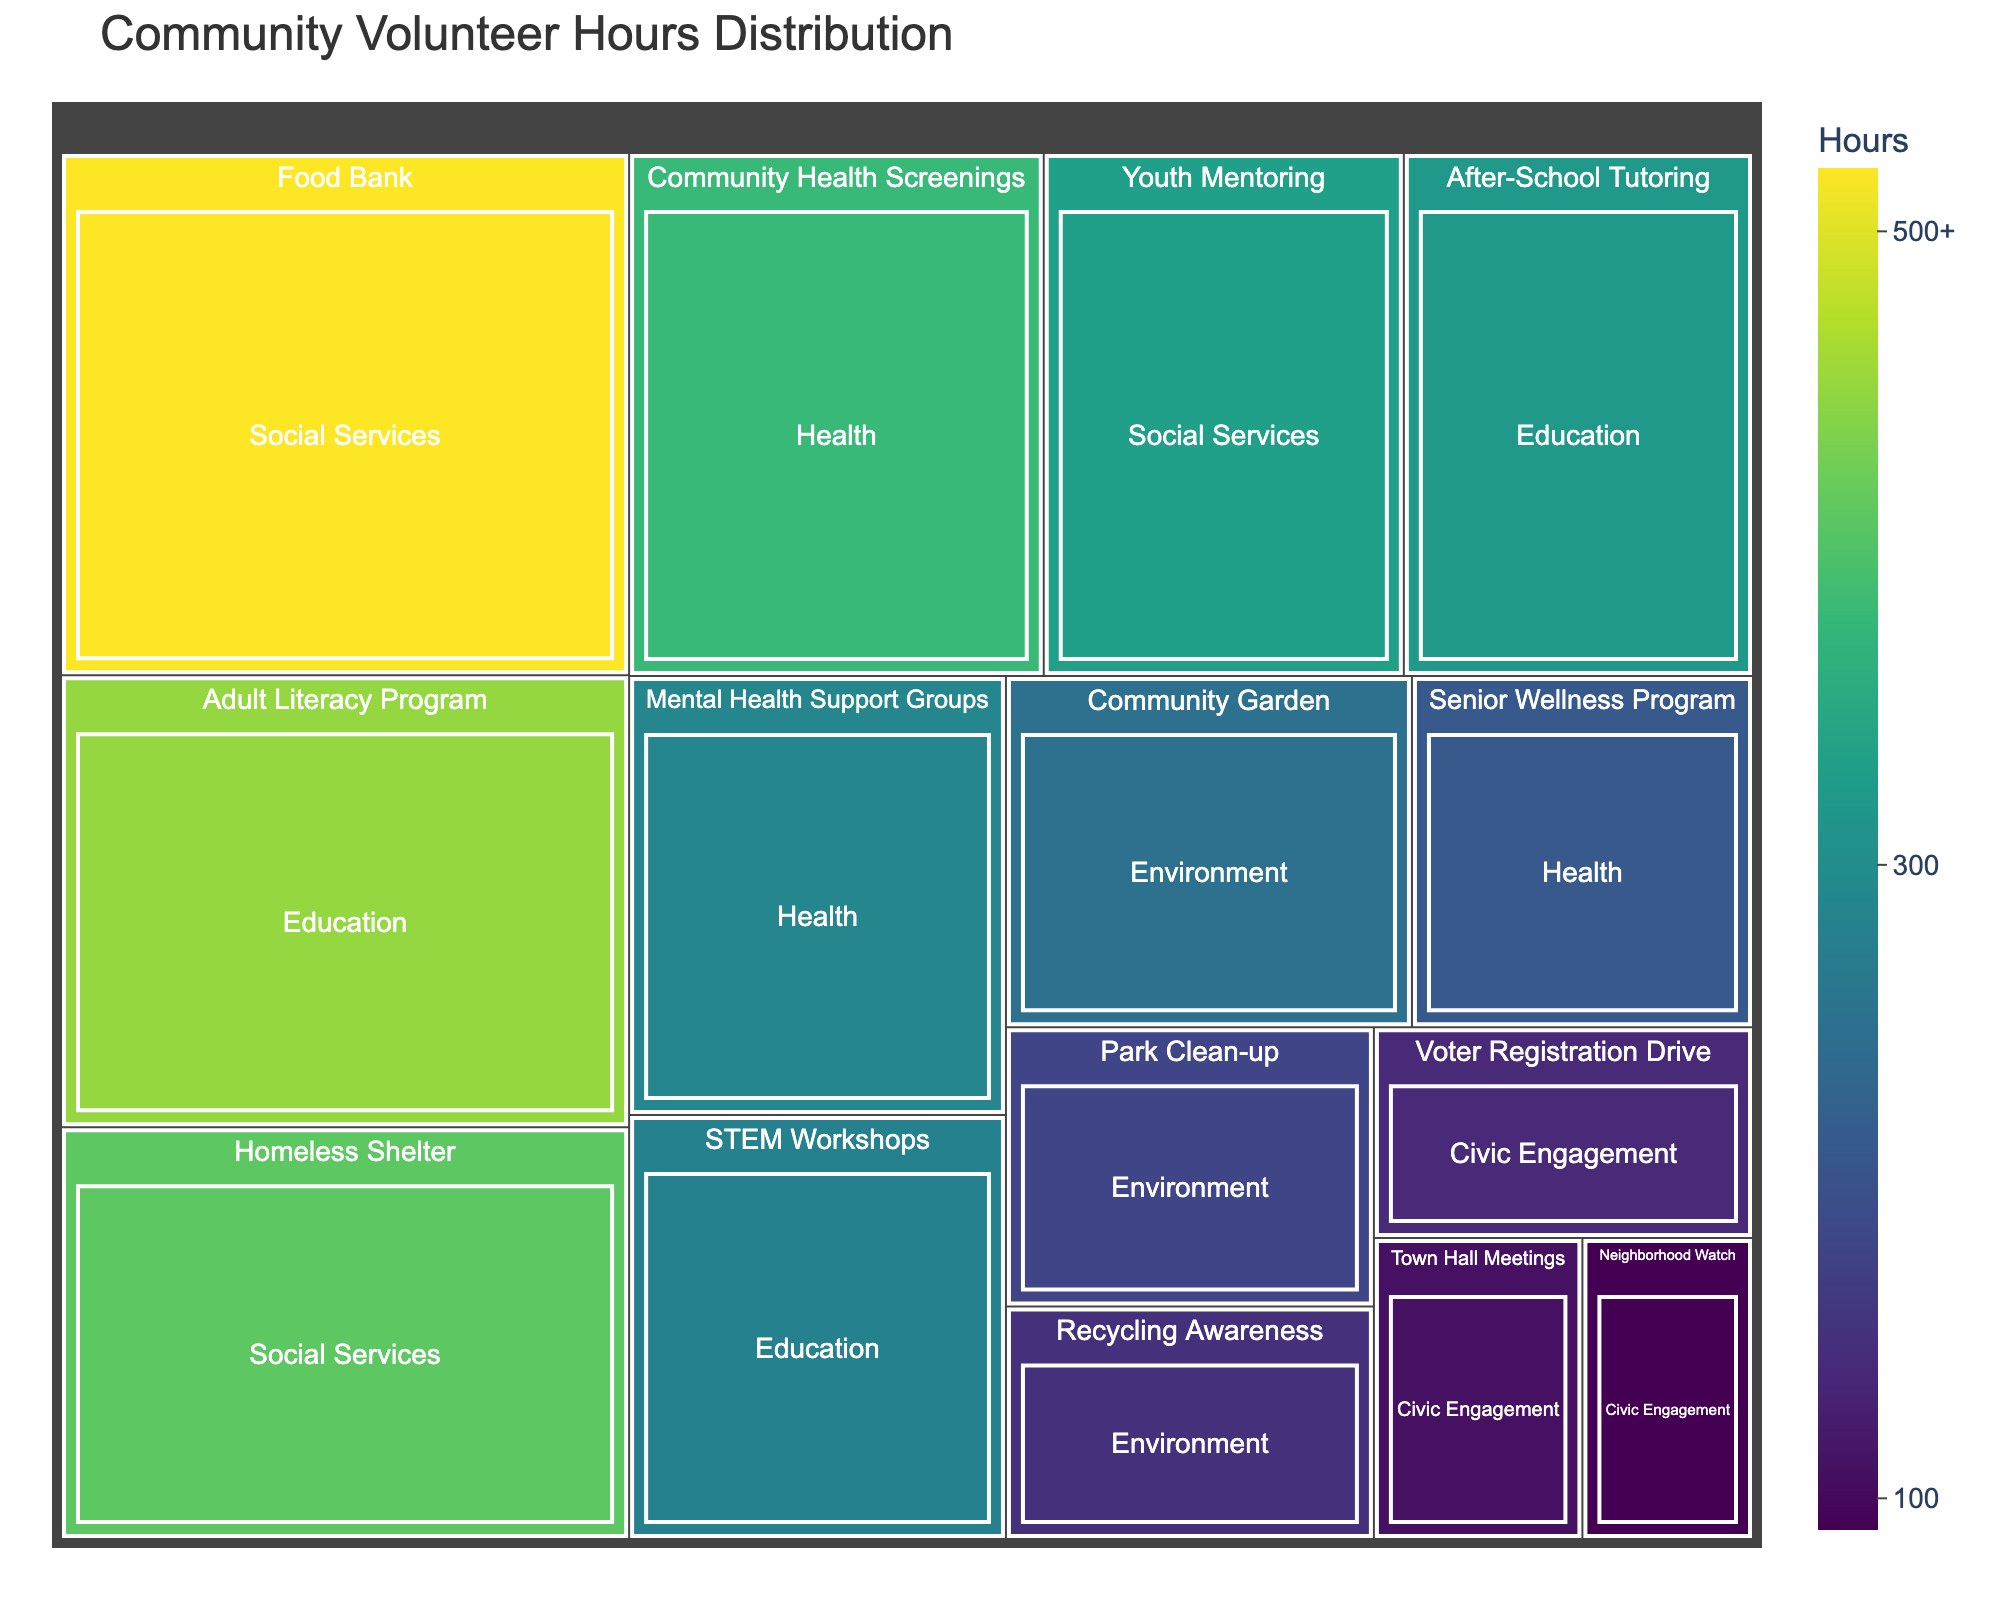What is the title of the treemap? The title is displayed at the top of the treemap and typically describes the overall content of the visual representation.
Answer: Community Volunteer Hours Distribution How many categories of initiatives are represented in the treemap? Categories are groupings of the different initiatives, and in the treemap, they are labeled as: Education, Health, Environment, Social Services, and Civic Engagement. Count these groups.
Answer: 5 Which initiative has the highest number of volunteer hours? Look for the largest block in the treemap or the one with the highest number of hours.
Answer: Food Bank What is the total number of volunteer hours for Education initiatives? Sum the hours of all initiatives under the Education category: Adult Literacy Program (450), After-School Tutoring (320), STEM Workshops (280). 450 + 320 + 280 = 1050
Answer: 1050 Which category has the least total volunteer hours? Compare the summed hours of all initiatives within each category. The category with the smallest sum has the least total volunteer hours.
Answer: Civic Engagement Which initiative within the Health category has the least number of volunteer hours? Identify the smallest block within the Health category by looking at the number of hours.
Answer: Senior Wellness Program How do the volunteer hours of the Community Health Screenings compare to those of Mental Health Support Groups? Compare the numbers directly: Community Health Screenings have 380 hours, Mental Health Support Groups have 290 hours. 380 is greater than 290.
Answer: Greater What is the average number of volunteer hours for Social Services initiatives? Sum the hours for initiatives in Social Services and divide by the number of initiatives: (Food Bank (520) + Homeless Shelter (410) + Youth Mentoring (330)) / 3. (520 + 410 + 330) / 3 = 1260 / 3 = 420
Answer: 420 What color is used to represent the initiative with the largest volunteer hours? The treemap uses a color scale where the depth of color can indicate the number of hours. The Food Bank (520 hours), as the largest block, uses the color at the deeper end of the Viridis scale.
Answer: Dark Green What is the combined number of volunteer hours for the Environment category initiatives? Sum the hours of all initiatives under the Environment category: Park Clean-up (180), Community Garden (250), Recycling Awareness (150). 180 + 250 + 150 = 580
Answer: 580 